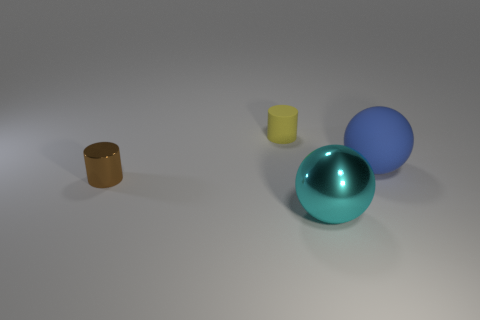Add 4 large shiny objects. How many objects exist? 8 Subtract all blue balls. How many balls are left? 1 Add 1 tiny brown objects. How many tiny brown objects are left? 2 Add 4 big yellow matte cylinders. How many big yellow matte cylinders exist? 4 Subtract 1 yellow cylinders. How many objects are left? 3 Subtract all gray spheres. Subtract all cyan cubes. How many spheres are left? 2 Subtract all big blue spheres. Subtract all yellow cubes. How many objects are left? 3 